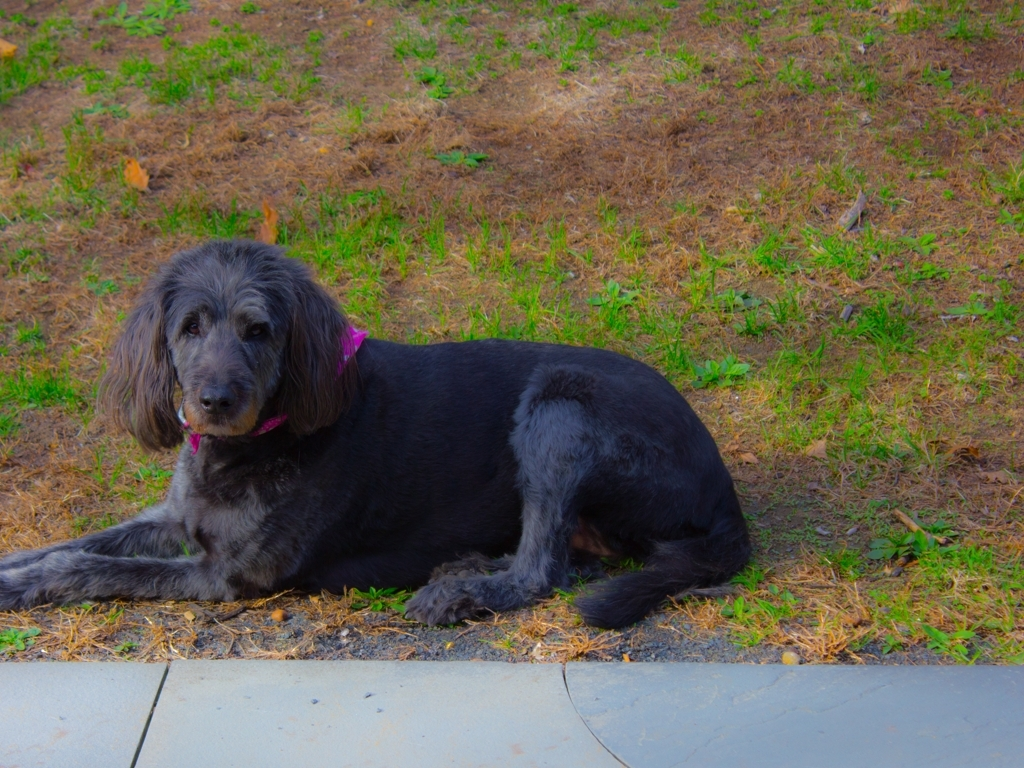What time of year does it seem to be in this image? Given the mix of green and brown grass and the presence of fallen leaves, it could be early fall or the end of summer. The lighting also suggests it might be late afternoon or early evening. 